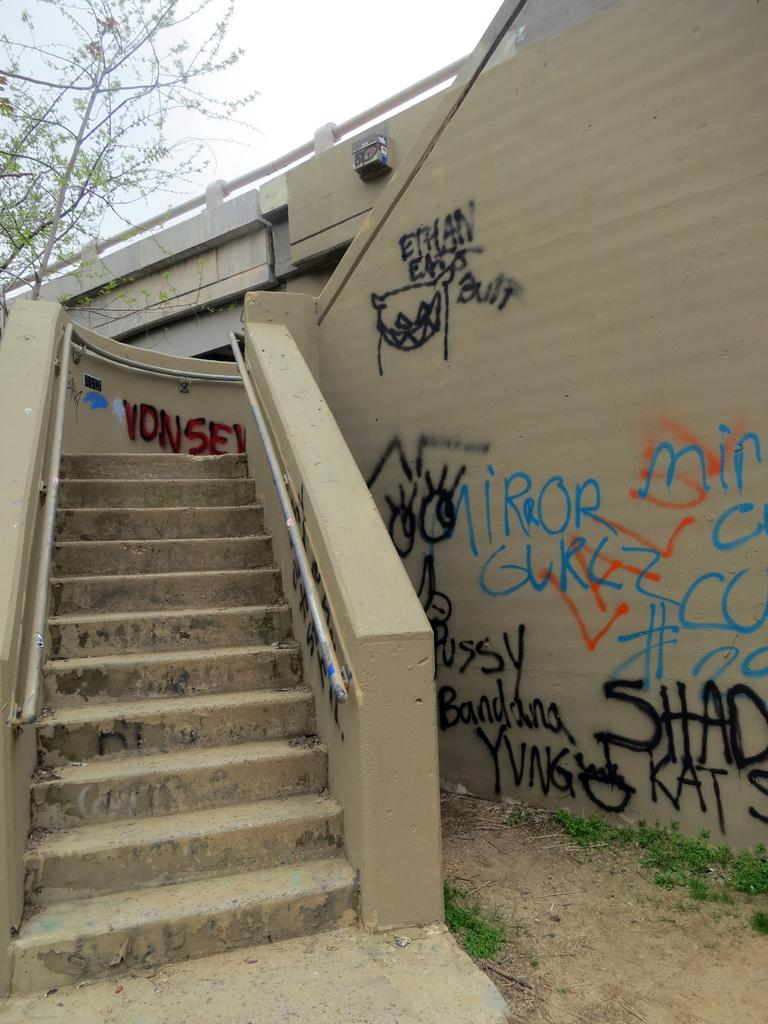What type of architectural feature can be seen in the image? There are steps in the image. What type of natural environment is visible in the image? There is grass in the image. What is on the wall in the image? There are paintings on the wall in the image. What type of vegetation is present in the image? There are trees in the image. What can be seen in the background of the image? The sky is visible in the background of the image. What type of tail is visible on the tree in the image? There are no tails visible on the trees in the image; they are regular trees without any animal appendages. Is there a chain connecting the steps and the wall in the image? There is no chain connecting the steps and the wall in the image; the steps and wall are separate elements. 